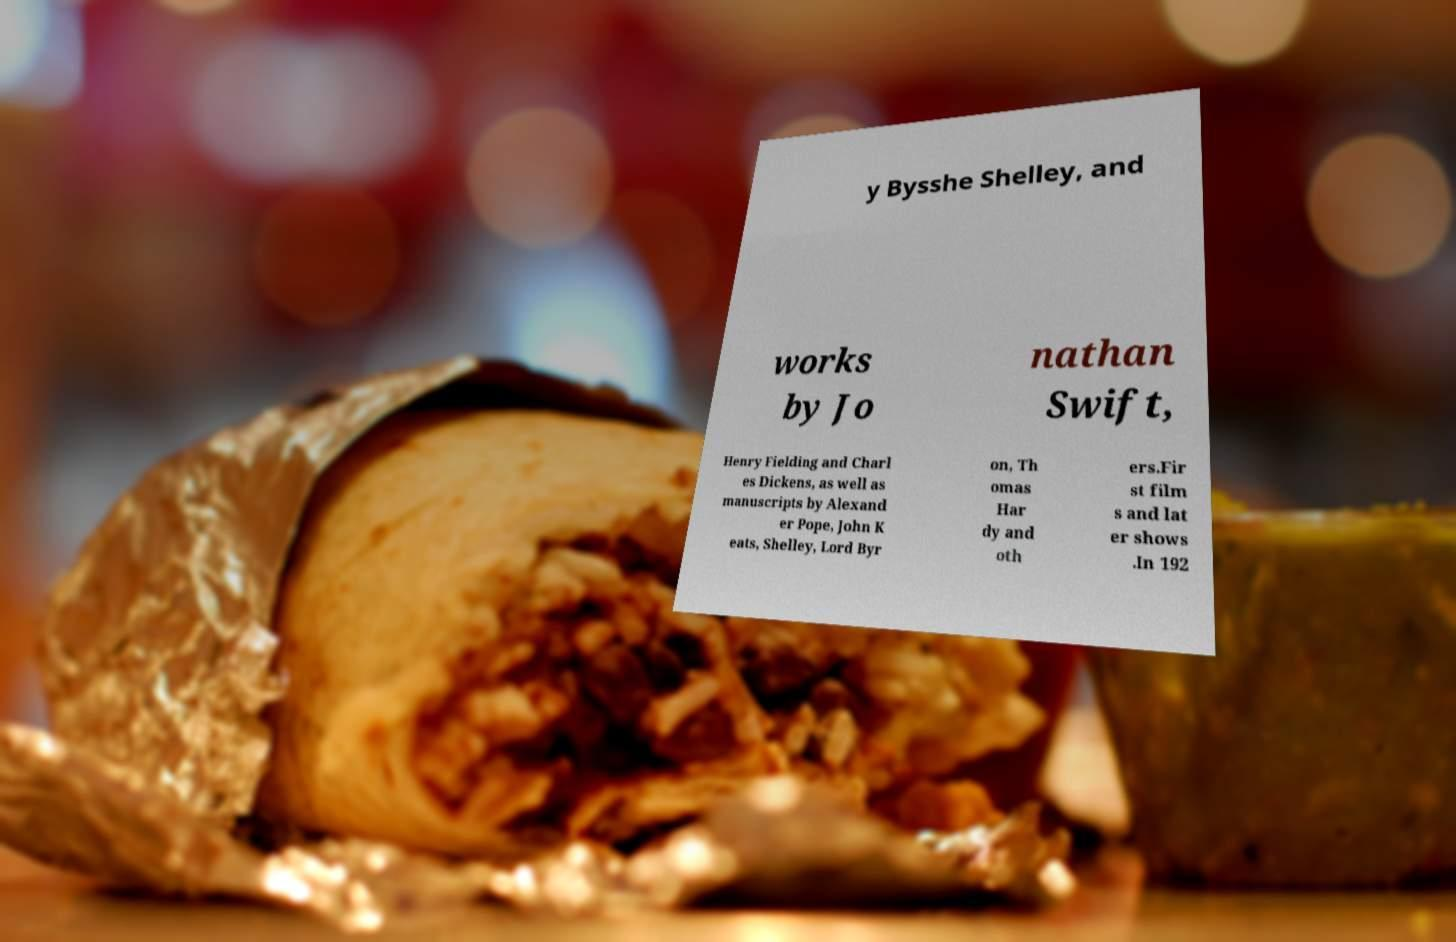Please read and relay the text visible in this image. What does it say? y Bysshe Shelley, and works by Jo nathan Swift, Henry Fielding and Charl es Dickens, as well as manuscripts by Alexand er Pope, John K eats, Shelley, Lord Byr on, Th omas Har dy and oth ers.Fir st film s and lat er shows .In 192 